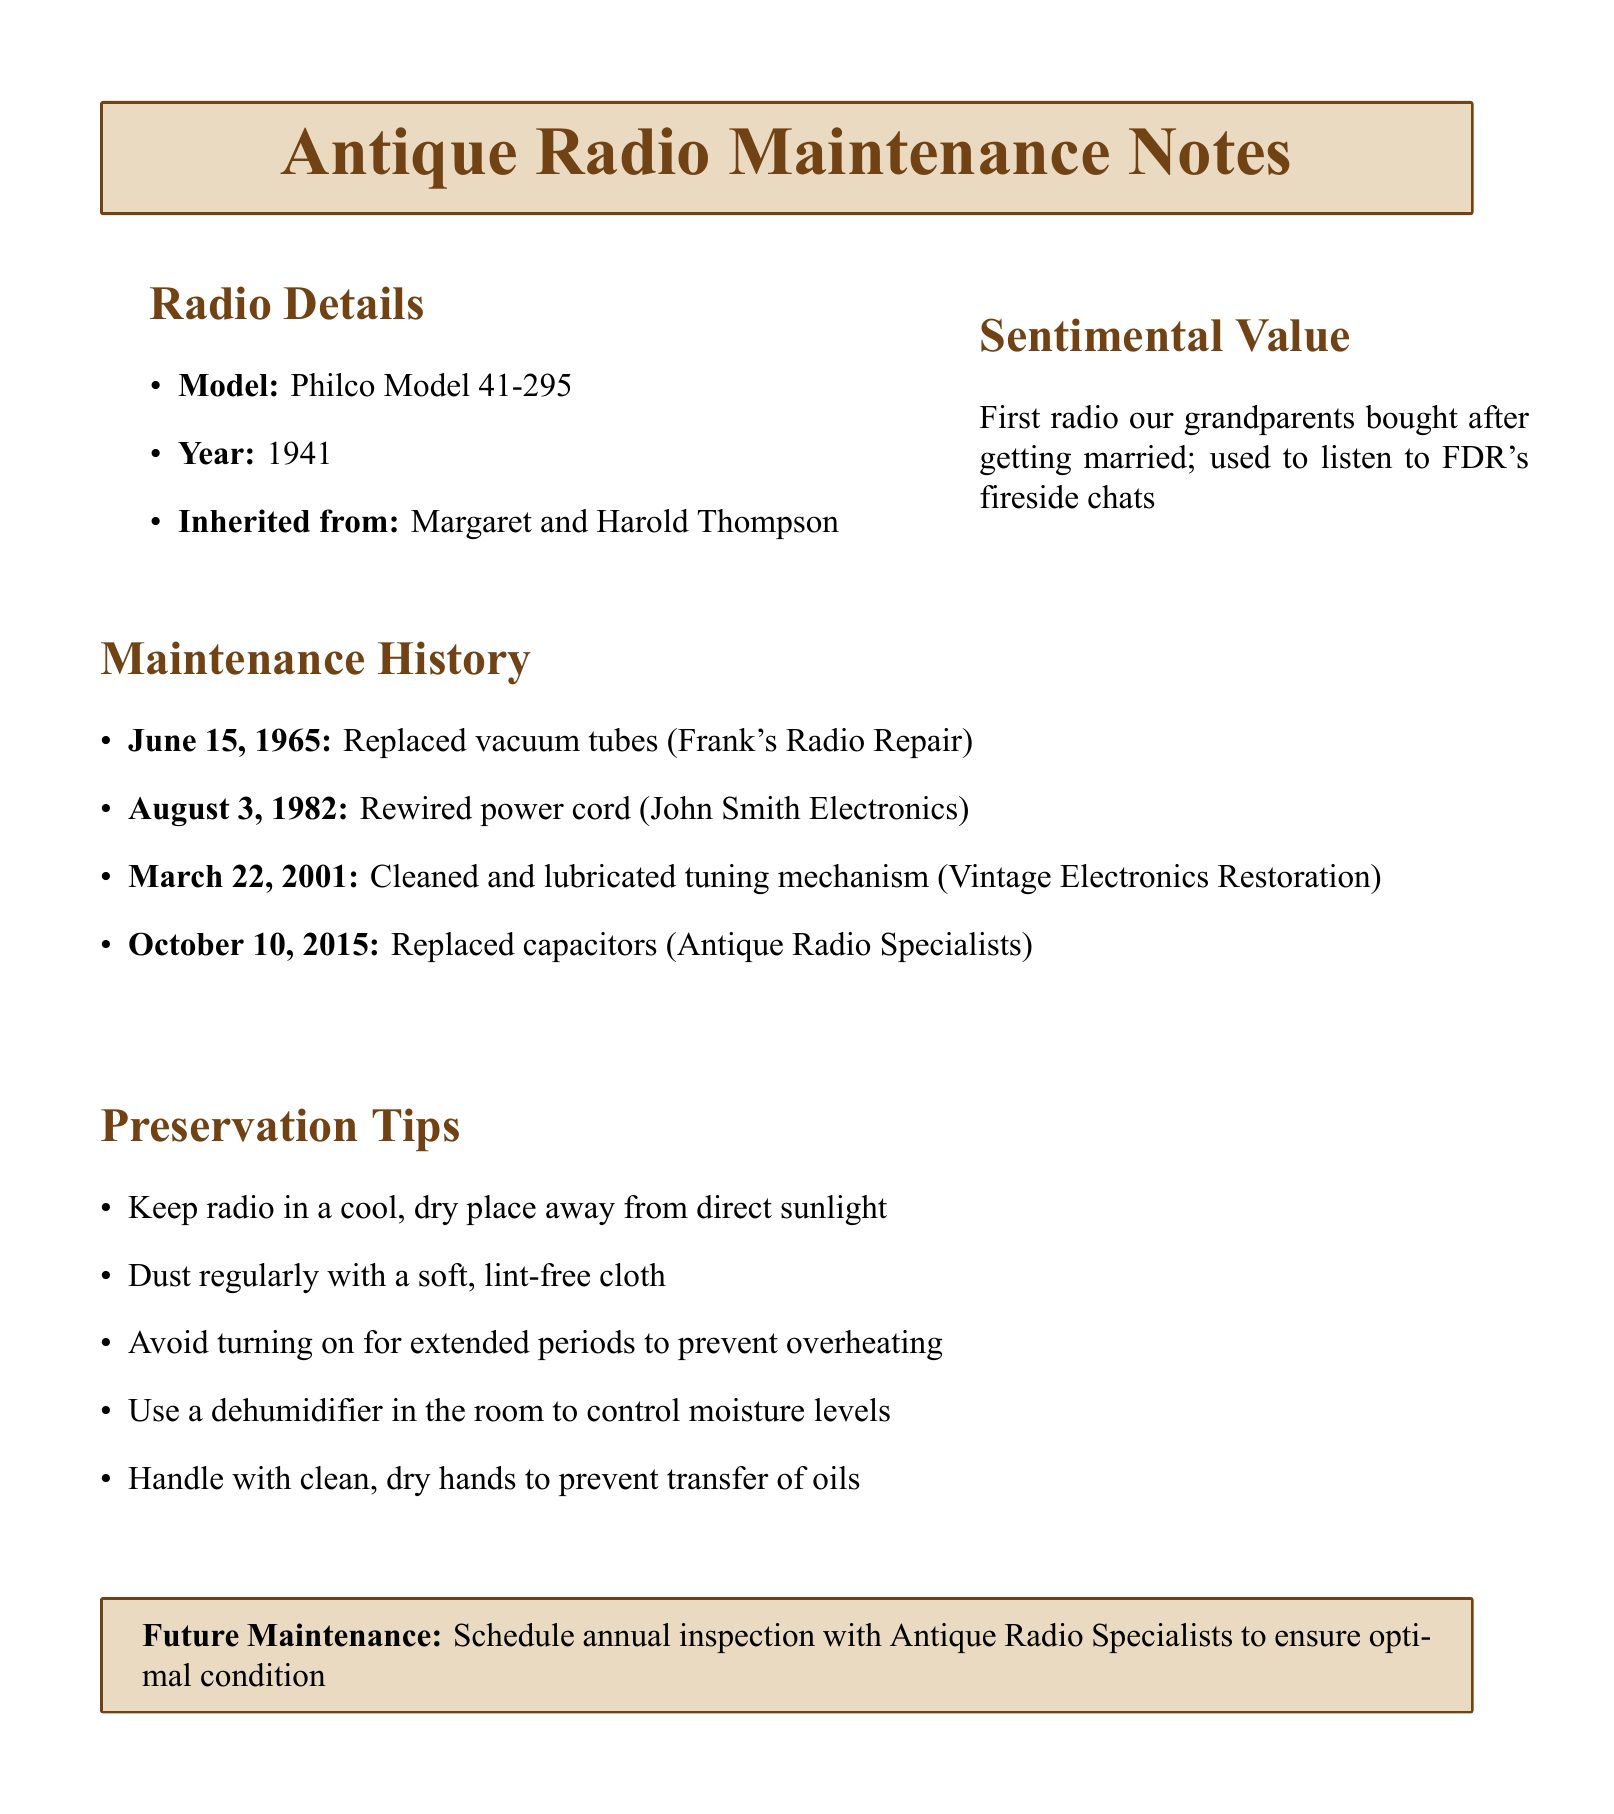What is the model of the radio? The model of the radio is explicitly mentioned in the document details.
Answer: Philco Model 41-295 Who performed the rewiring of the power cord? The technician who performed the rewiring is listed in the maintenance history.
Answer: John Smith Electronics When was the radio's tuning mechanism cleaned and lubricated? The date of this maintenance work is stated in the document.
Answer: March 22, 2001 What is one of the preservation tips? Preservation tips are provided in a dedicated section and include various suggestions.
Answer: Keep radio in a cool, dry place away from direct sunlight What sentimental event is associated with the radio? The document describes the sentimental value of the radio related to its history.
Answer: First radio our grandparents bought after getting married How often should the radio be inspected in the future? The future maintenance section mentions the frequency of inspections.
Answer: Annually What work was done on October 10, 2015? The maintenance history specifies what repair was performed on that date.
Answer: Replaced capacitors Which technician replaced the vacuum tubes? The maintenance history includes the service provider for this work.
Answer: Frank's Radio Repair What is the year of the radio's manufacture? The year is explicitly stated in the radio details.
Answer: 1941 